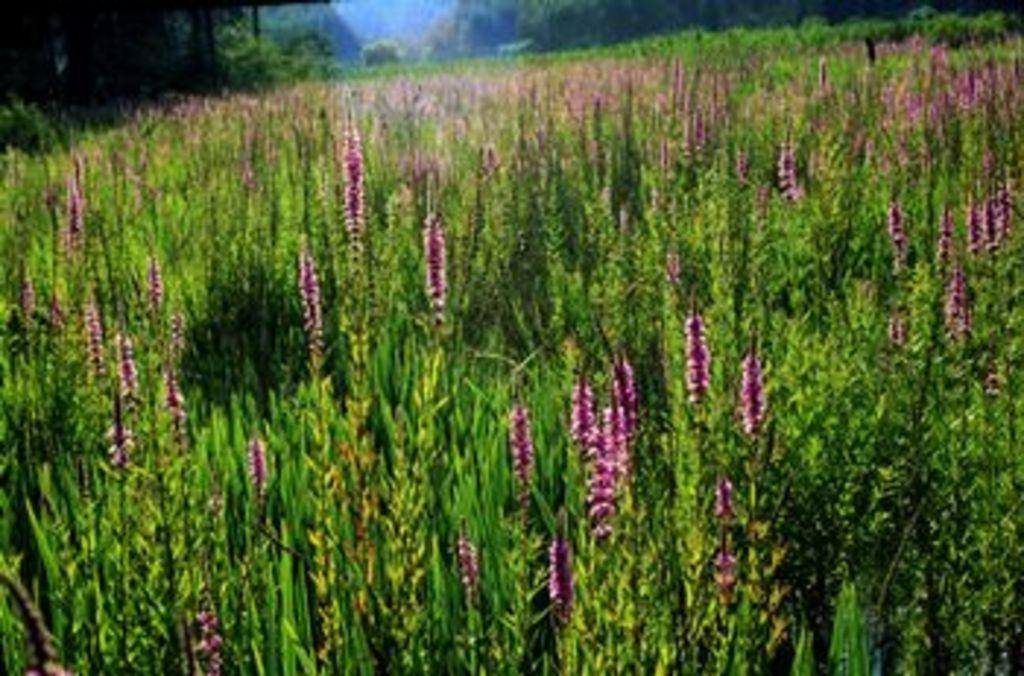What type of plants can be seen in the image? There are flower plants in the image. What else can be seen in the image besides the flower plants? There are trees visible at the top of the image. What unit of currency is being used to purchase the flowers in the image? There is no indication of currency or a transaction in the image; it simply shows flower plants and trees. 